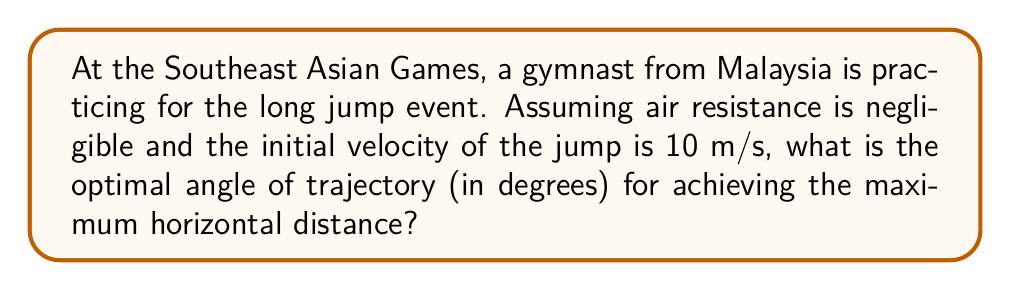Could you help me with this problem? To find the optimal angle for the long jump, we need to consider the projectile motion equations and maximize the horizontal distance. Let's break this down step-by-step:

1. The horizontal distance (range) of a projectile launched from ground level is given by:

   $$R = \frac{v_0^2 \sin(2\theta)}{g}$$

   Where:
   $R$ is the range (horizontal distance)
   $v_0$ is the initial velocity
   $\theta$ is the launch angle
   $g$ is the acceleration due to gravity (9.8 m/s²)

2. To find the maximum range, we need to maximize $\sin(2\theta)$. The maximum value of sine is 1, which occurs when its argument is 90°.

3. Therefore, the maximum range occurs when:

   $$2\theta = 90°$$
   $$\theta = 45°$$

4. We can verify this by taking the derivative of the range equation with respect to $\theta$ and setting it to zero:

   $$\frac{dR}{d\theta} = \frac{v_0^2}{g} \cdot 2\cos(2\theta) = 0$$

   This is true when $\cos(2\theta) = 0$, which again occurs when $2\theta = 90°$ or $\theta = 45°$.

5. The optimal angle is independent of the initial velocity, so it remains 45° regardless of how fast the gymnast jumps.

[asy]
import geometry;

size(200);
draw((-1,0)--(5,0), arrow=Arrow(TeXHead));
draw((0,-0.5)--(0,3), arrow=Arrow(TeXHead));
draw((0,0)--(3,3), arrow=Arrow(TeXHead));

label("x", (5,0), E);
label("y", (0,3), N);
label("$v_0$", (1.5,1.5), NE);
label("45°", (0.5,0.2), NE);

draw(arc((0,0),0.5,0,45), blue);
[/asy]

This diagram illustrates the optimal 45° launch angle for maximum range in projectile motion.
Answer: The optimal angle of trajectory for achieving the maximum horizontal distance in a long jump is 45°. 